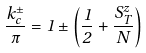Convert formula to latex. <formula><loc_0><loc_0><loc_500><loc_500>\frac { k _ { c } ^ { \pm } } { \pi } = 1 \pm \left ( \frac { 1 } { 2 } + \frac { S _ { T } ^ { z } } { N } \right )</formula> 